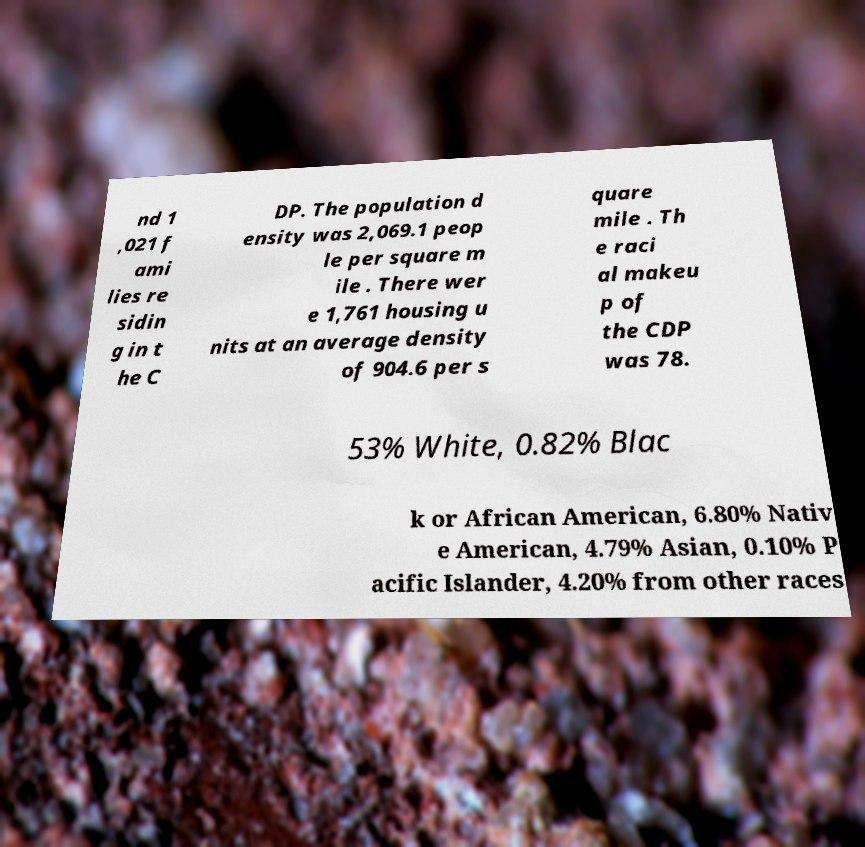Please identify and transcribe the text found in this image. nd 1 ,021 f ami lies re sidin g in t he C DP. The population d ensity was 2,069.1 peop le per square m ile . There wer e 1,761 housing u nits at an average density of 904.6 per s quare mile . Th e raci al makeu p of the CDP was 78. 53% White, 0.82% Blac k or African American, 6.80% Nativ e American, 4.79% Asian, 0.10% P acific Islander, 4.20% from other races 